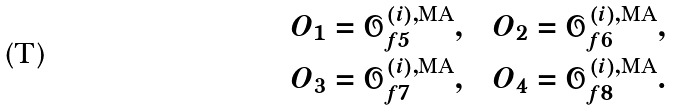<formula> <loc_0><loc_0><loc_500><loc_500>O _ { 1 } = \mathcal { O } _ { f 5 } ^ { ( i ) , \text {MA} } , \quad & O _ { 2 } = \mathcal { O } _ { f 6 } ^ { ( i ) , \text {MA} } , \\ O _ { 3 } = \mathcal { O } _ { f 7 } ^ { ( i ) , \text {MA} } , \quad & O _ { 4 } = \mathcal { O } _ { f 8 } ^ { ( i ) , \text {MA} } .</formula> 